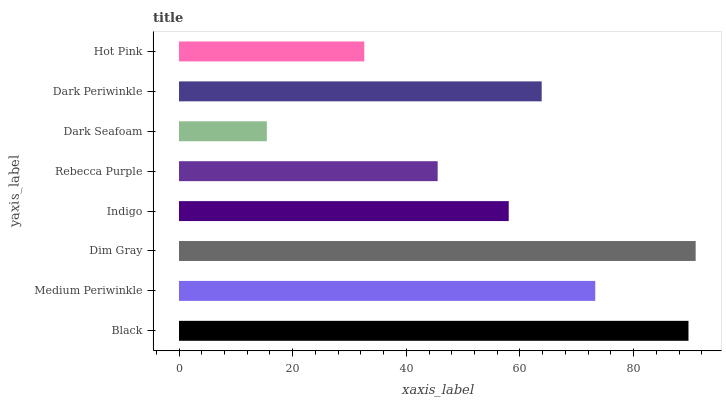Is Dark Seafoam the minimum?
Answer yes or no. Yes. Is Dim Gray the maximum?
Answer yes or no. Yes. Is Medium Periwinkle the minimum?
Answer yes or no. No. Is Medium Periwinkle the maximum?
Answer yes or no. No. Is Black greater than Medium Periwinkle?
Answer yes or no. Yes. Is Medium Periwinkle less than Black?
Answer yes or no. Yes. Is Medium Periwinkle greater than Black?
Answer yes or no. No. Is Black less than Medium Periwinkle?
Answer yes or no. No. Is Dark Periwinkle the high median?
Answer yes or no. Yes. Is Indigo the low median?
Answer yes or no. Yes. Is Indigo the high median?
Answer yes or no. No. Is Dark Periwinkle the low median?
Answer yes or no. No. 